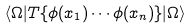<formula> <loc_0><loc_0><loc_500><loc_500>\langle \Omega | T \{ \phi ( x _ { 1 } ) \cdots \phi ( x _ { n } ) \} | \Omega \rangle</formula> 